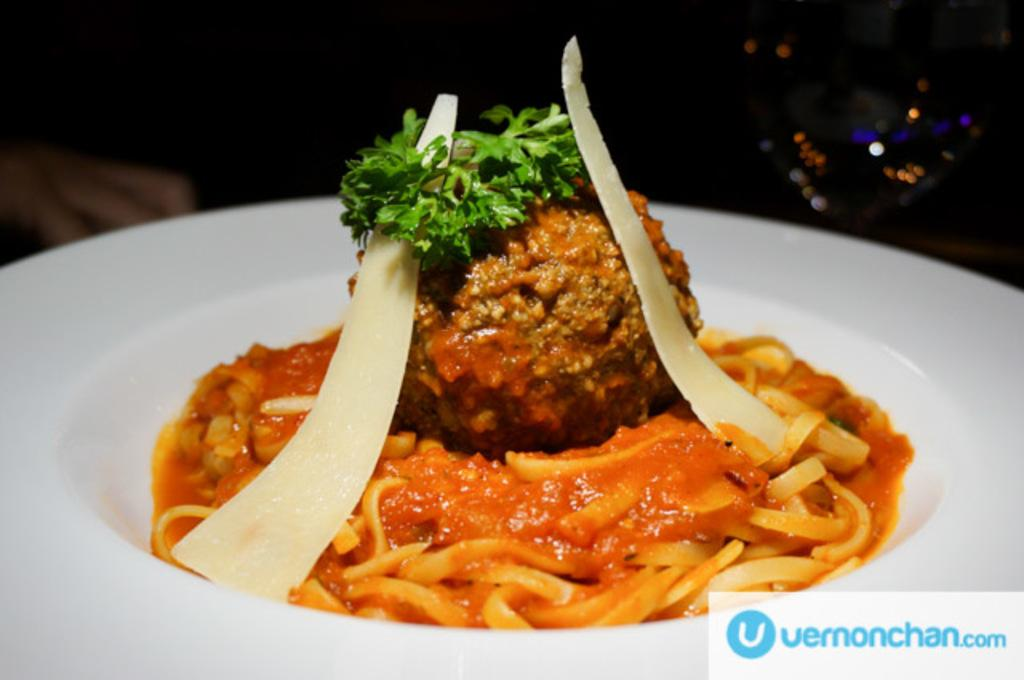What is on the plate in the image? There is food in the plate in the image. Where is the logo located in the image? The logo is at the right bottom of the image. What type of metal is used to sort the food in the image? There is no metal or sorting process depicted in the image; it simply shows food on a plate. 